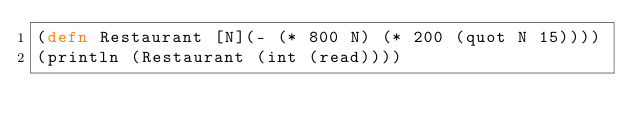Convert code to text. <code><loc_0><loc_0><loc_500><loc_500><_Clojure_>(defn Restaurant [N](- (* 800 N) (* 200 (quot N 15))))
(println (Restaurant (int (read))))</code> 